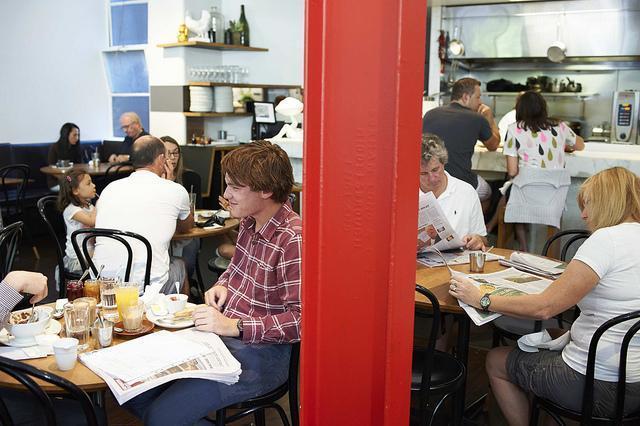How many people are sitting at the counter?
Give a very brief answer. 2. How many dining tables are visible?
Give a very brief answer. 2. How many people are there?
Give a very brief answer. 7. How many chairs can you see?
Give a very brief answer. 5. 